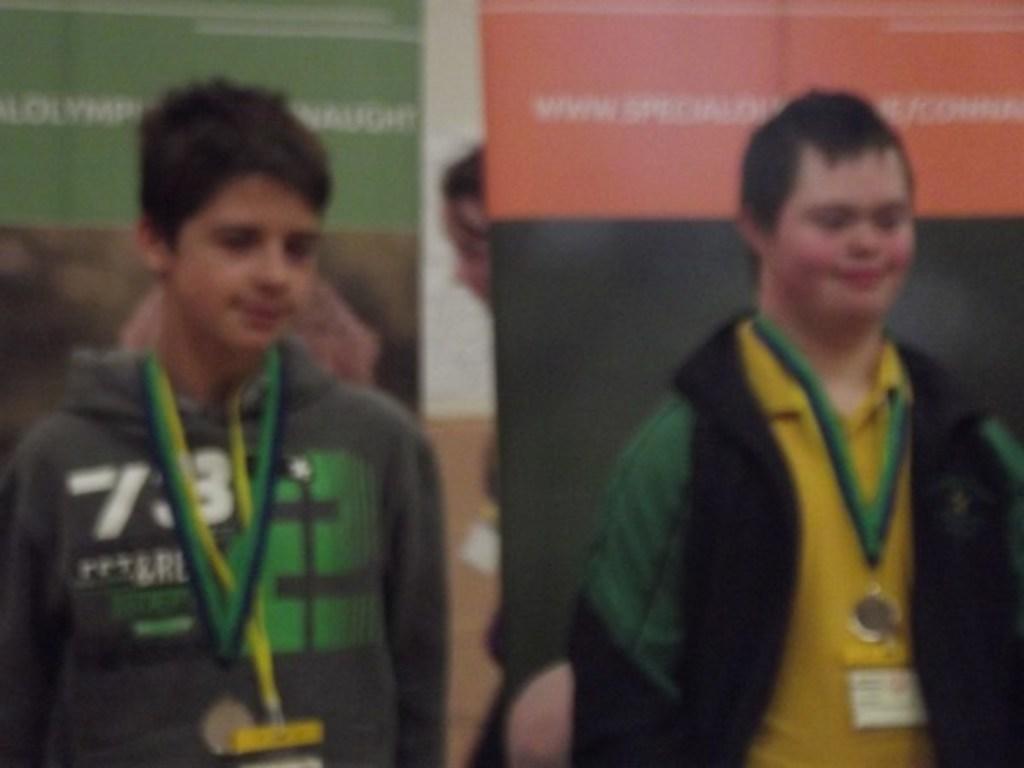How would you summarize this image in a sentence or two? This is a blurred picture. In the background we can see boards and partial part of a person is visible. In this picture we can see the men wearing medals and identification cards. 